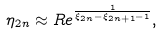Convert formula to latex. <formula><loc_0><loc_0><loc_500><loc_500>\eta _ { 2 n } \approx R e ^ { \frac { 1 } { \xi _ { 2 n } - \xi _ { 2 n + 1 } - 1 } } ,</formula> 